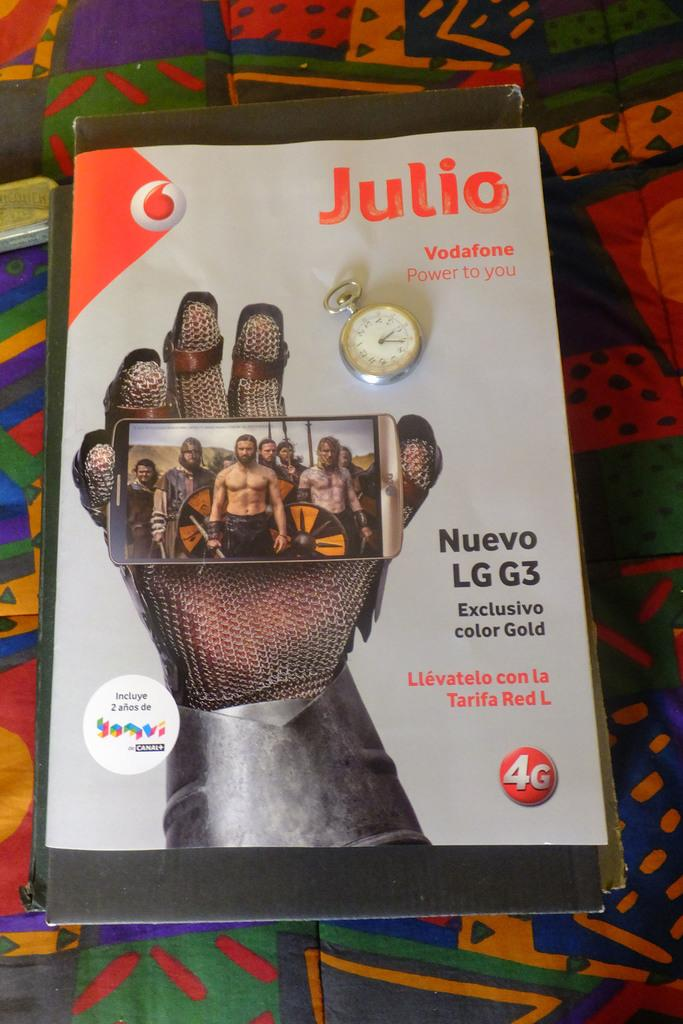<image>
Share a concise interpretation of the image provided. Magazine cover showing a hand holding a phone and the name JULIO on top. 